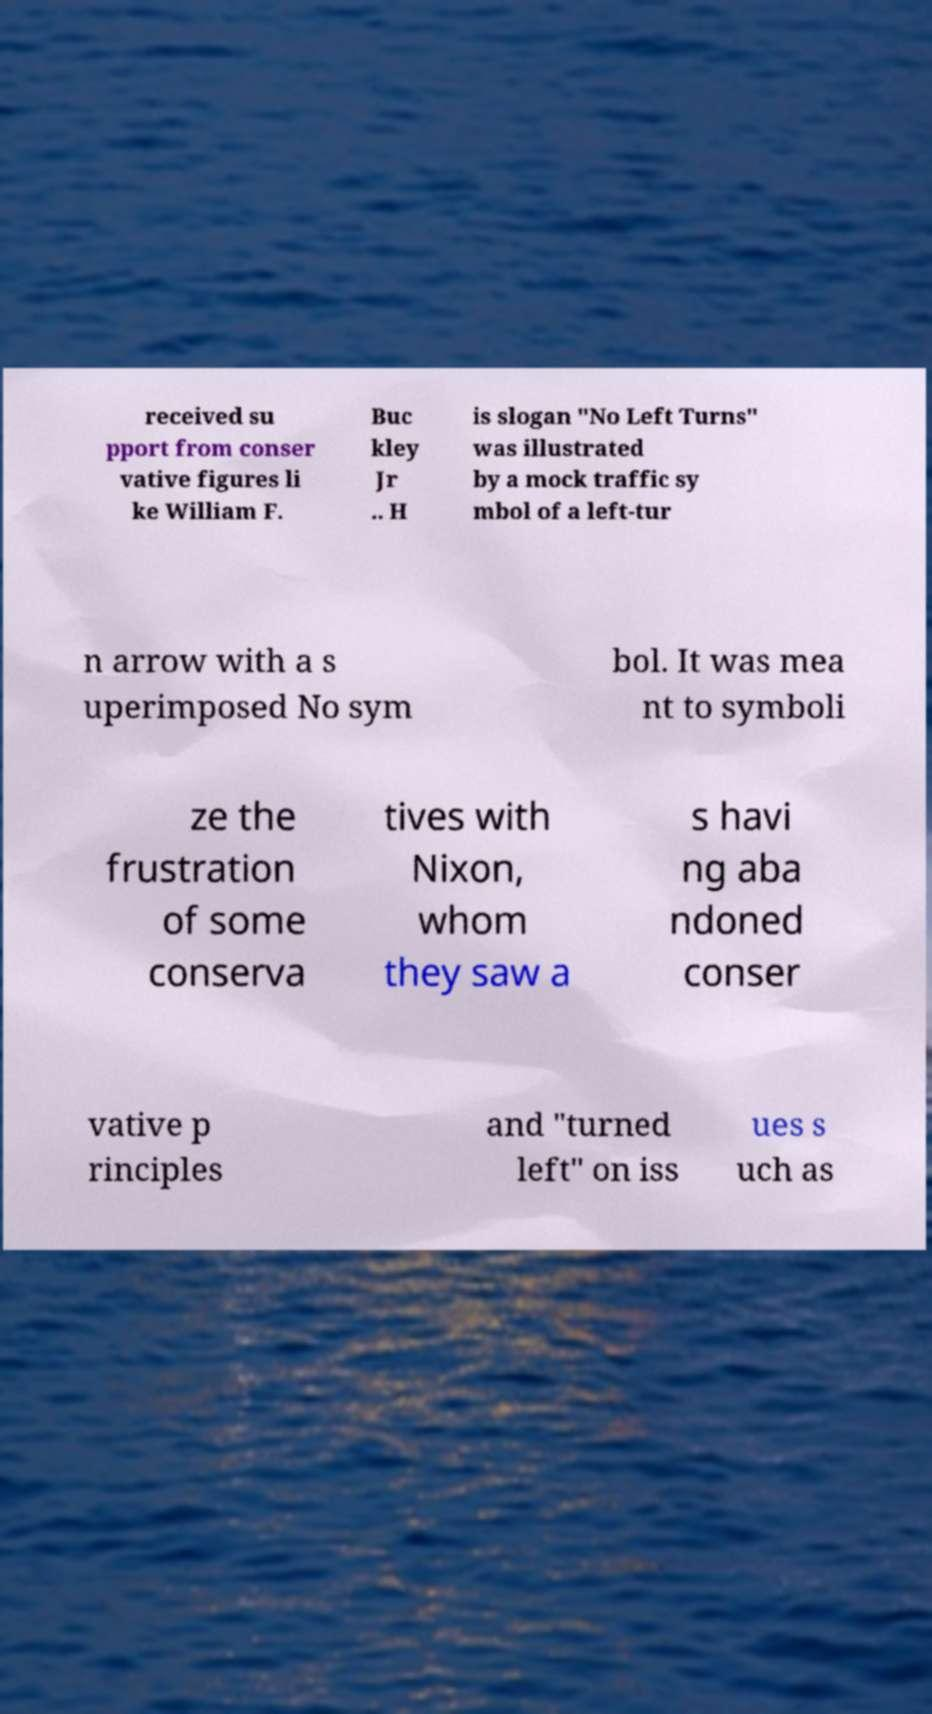Can you read and provide the text displayed in the image?This photo seems to have some interesting text. Can you extract and type it out for me? received su pport from conser vative figures li ke William F. Buc kley Jr .. H is slogan "No Left Turns" was illustrated by a mock traffic sy mbol of a left-tur n arrow with a s uperimposed No sym bol. It was mea nt to symboli ze the frustration of some conserva tives with Nixon, whom they saw a s havi ng aba ndoned conser vative p rinciples and "turned left" on iss ues s uch as 